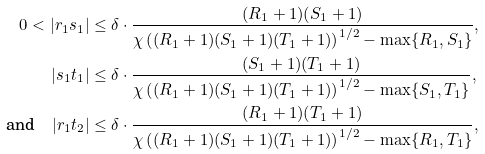Convert formula to latex. <formula><loc_0><loc_0><loc_500><loc_500>0 < | r _ { 1 } s _ { 1 } | & \leq \delta \cdot \frac { ( R _ { 1 } + 1 ) ( S _ { 1 } + 1 ) } { \chi \left ( ( R _ { 1 } + 1 ) ( S _ { 1 } + 1 ) ( T _ { 1 } + 1 ) \right ) ^ { 1 / 2 } - \max \{ R _ { 1 } , S _ { 1 } \} } , \\ | s _ { 1 } t _ { 1 } | & \leq \delta \cdot \frac { ( S _ { 1 } + 1 ) ( T _ { 1 } + 1 ) } { \chi \left ( ( R _ { 1 } + 1 ) ( S _ { 1 } + 1 ) ( T _ { 1 } + 1 ) \right ) ^ { 1 / 2 } - \max \{ S _ { 1 } , T _ { 1 } \} } , \\ \text {and} \quad | r _ { 1 } t _ { 2 } | & \leq \delta \cdot \frac { ( R _ { 1 } + 1 ) ( T _ { 1 } + 1 ) } { \chi \left ( ( R _ { 1 } + 1 ) ( S _ { 1 } + 1 ) ( T _ { 1 } + 1 ) \right ) ^ { 1 / 2 } - \max \{ R _ { 1 } , T _ { 1 } \} } , \\</formula> 